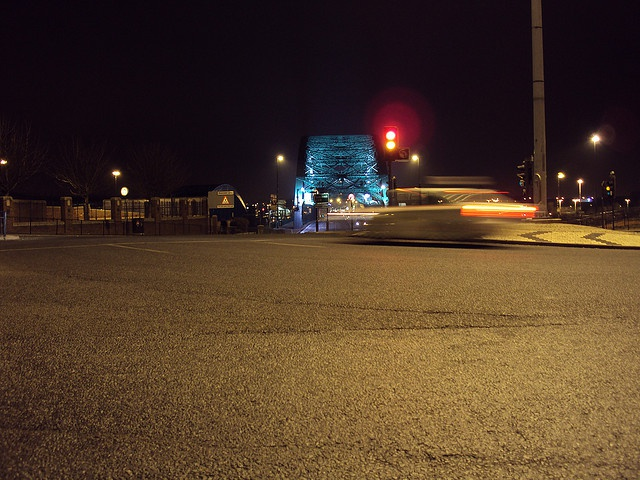Describe the objects in this image and their specific colors. I can see a traffic light in black, maroon, ivory, and red tones in this image. 